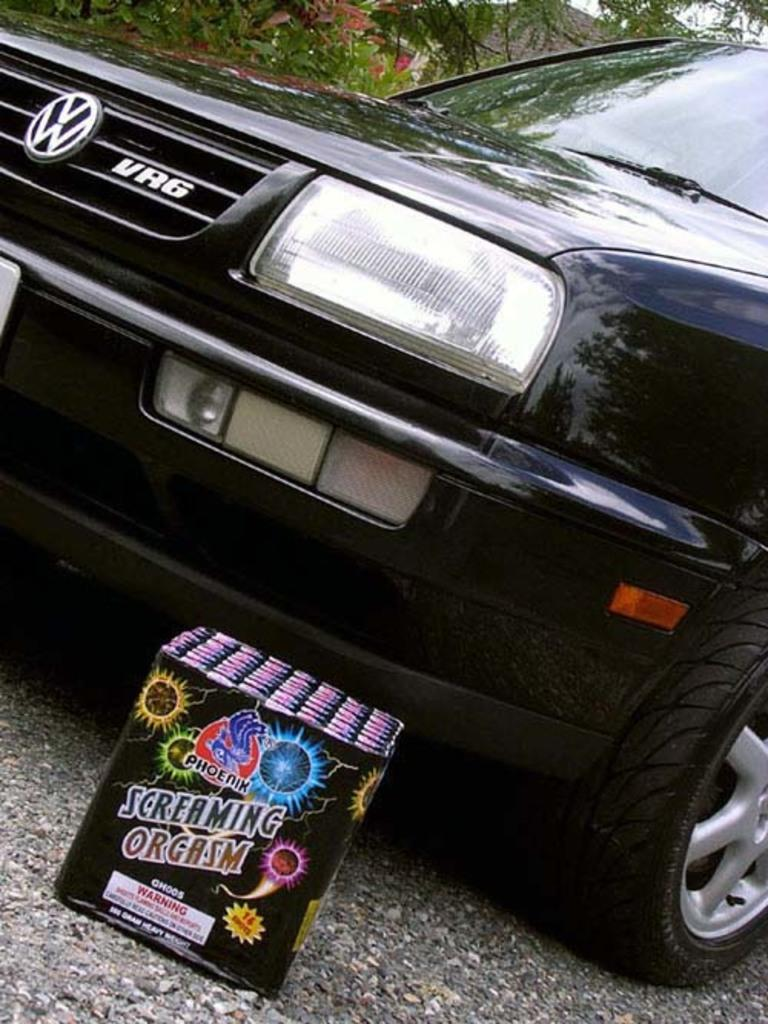What is the main subject of the image? There is a car in the image. What else can be seen on the road in the image? There is a cardboard box on the road in the image. What type of natural scenery is visible in the image? Trees are visible at the top of the image. Reasoning: Let'g: Let's think step by step in order to produce the conversation. We start by identifying the main subject of the image, which is the car. Then, we describe other objects and elements in the image, such as the cardboard box on the road and the trees at the top of the image. Each question is designed to elicit a specific detail about the image that is known from the provided facts. Absurd Question/Answer: What type of silverware is visible on the shelf in the image? There is no silverware or shelf present in the image. 